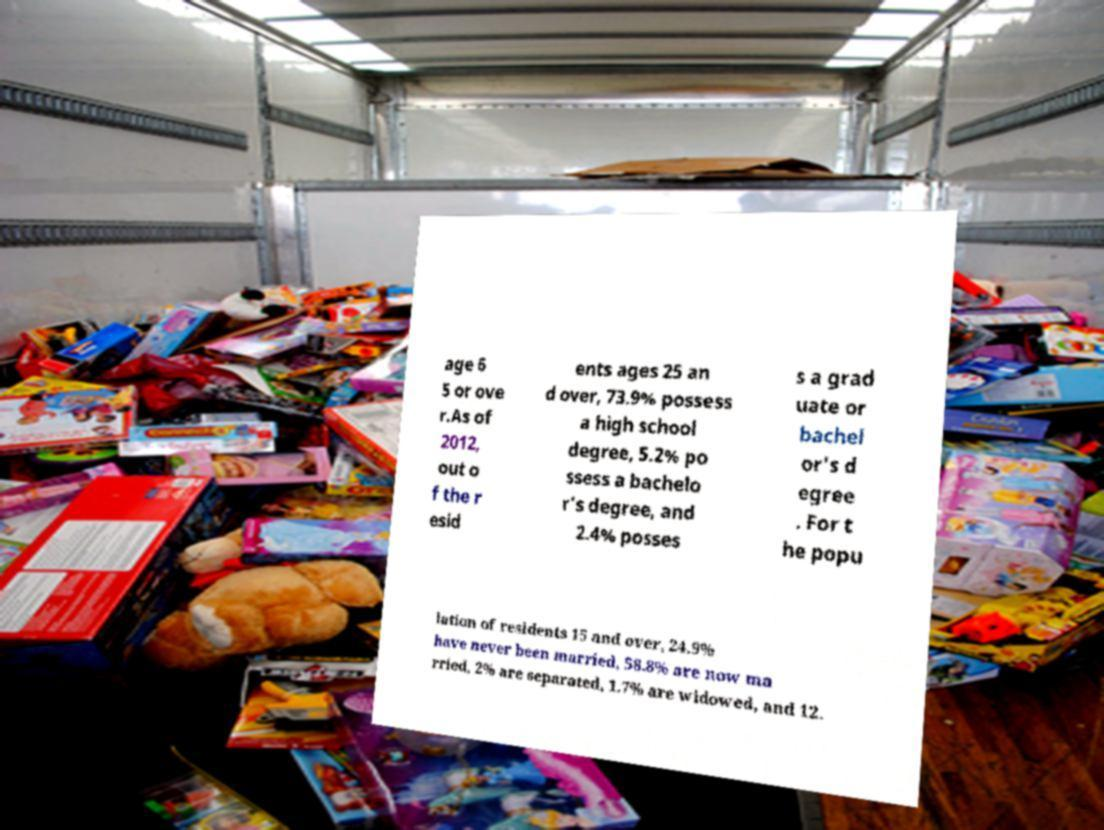Please read and relay the text visible in this image. What does it say? age 6 5 or ove r.As of 2012, out o f the r esid ents ages 25 an d over, 73.9% possess a high school degree, 5.2% po ssess a bachelo r's degree, and 2.4% posses s a grad uate or bachel or's d egree . For t he popu lation of residents 15 and over, 24.9% have never been married, 58.8% are now ma rried, 2% are separated, 1.7% are widowed, and 12. 